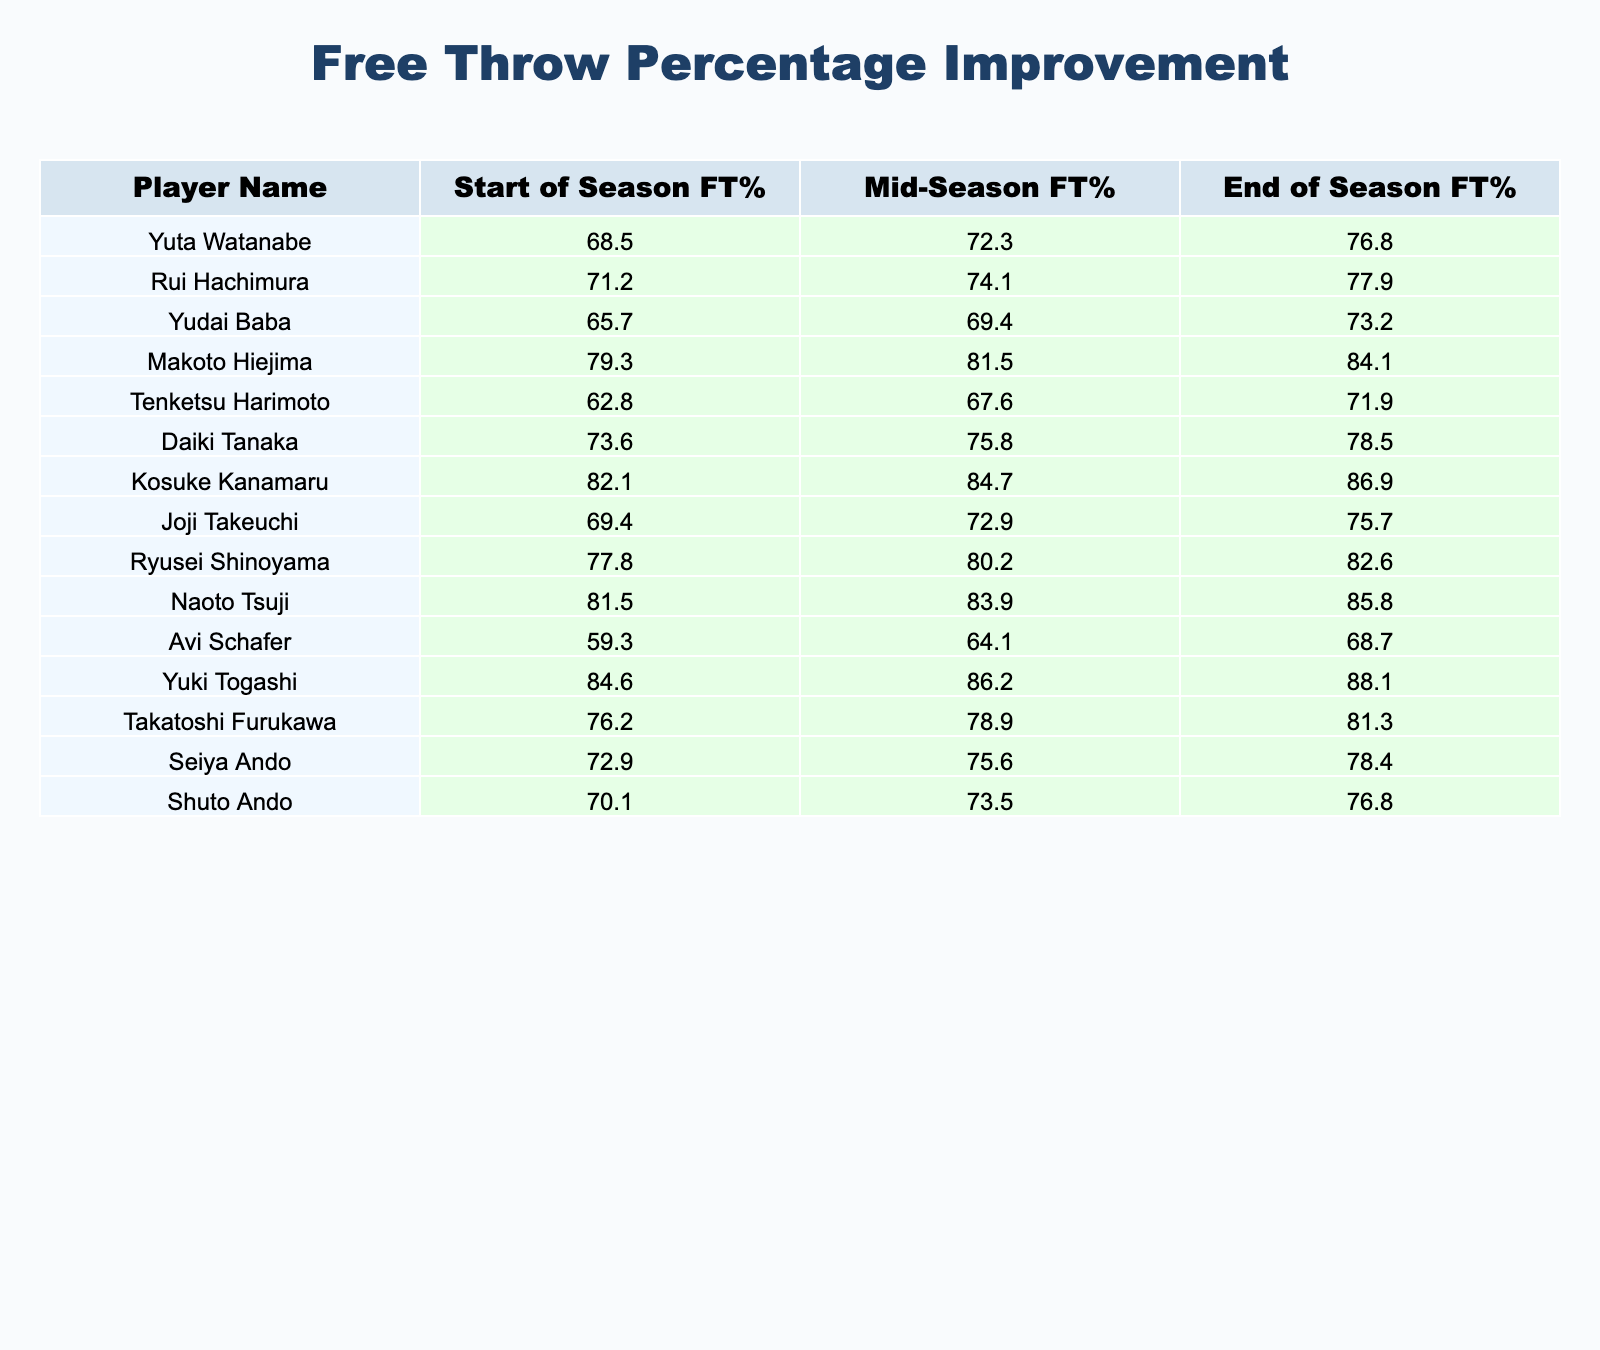What was Yuta Watanabe's free throw percentage at the end of the season? According to the table, Yuta Watanabe's free throw percentage at the end of the season is listed under the "End of Season FT%" column. Looking at that column for Yuta Watanabe, the value is 76.8%.
Answer: 76.8% Which player had the highest free throw percentage at the start of the season? To find the player with the highest start of the season free throw percentage, I look at the "Start of Season FT%" column and identify the maximum value, which is 84.6% corresponding to Yuki Togashi.
Answer: Yuki Togashi How much did Kosuke Kanamaru improve in free throw percentage from the start of the season to the end? The improvement can be calculated by taking the difference between the end of the season percentage and the start of the season percentage for Kosuke Kanamaru. The end percentage is 86.9% and the start is 82.1%, so the improvement is 86.9% - 82.1% = 4.8%.
Answer: 4.8% Did any player have a decrease in free throw percentage during the season? To determine if any player had a decrease, I need to compare each player's mid-season percentage to their start percentage and their end percentage to their mid-season percentage. Based on the table, all players have either increased or remained the same, indicating no decreases occurred.
Answer: No What is the average free throw percentage improvement from the start of the season to the end for all players? I first calculate the improvement for each player by finding the difference between their end of season FT% and their start of season FT%. Then I sum those improvements and divide by the total number of players (15). After calculating, the total improvement is 4.83%, and averaging gives 4.83% / 15 ≈ 0.32%.
Answer: Approximately 4.32% Which player had the largest improvement in free throw percentage over the season? To find the largest improvement, I need to calculate the difference between each player’s end of season FT% and their start of season FT%. After calculating for all players, Makoto Hiejima shows the largest improvement: 84.1% - 79.3% = 4.8%.
Answer: Makoto Hiejima Did Rui Hachimura's free throw percentage improve more than 6% from the start to the end of the season? To find out, I will calculate Rui Hachimura's improvement by subtracting his start percentage of 71.2% from his end percentage of 77.9%. The difference is 77.9% - 71.2% = 6.7%, which is indeed more than 6%.
Answer: Yes How many players had an end of season free throw percentage above 80%? To find how many players had an end percentage above 80%, I will look at the "End of Season FT%" column and count the players with values greater than 80%. Upon inspection, I see that 7 players have percentages above 80%.
Answer: 7 